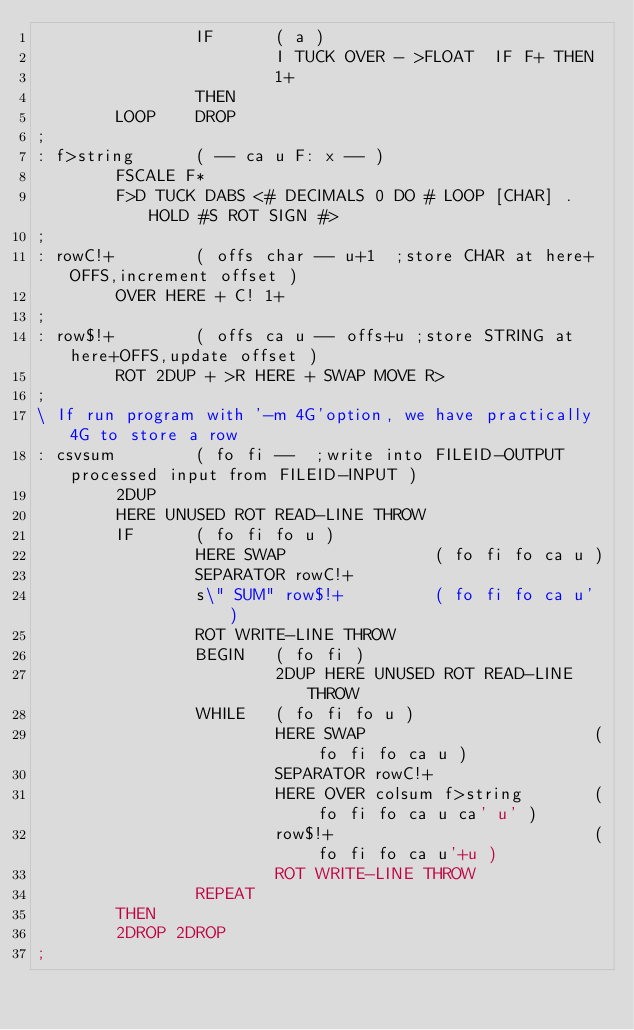<code> <loc_0><loc_0><loc_500><loc_500><_Forth_>                IF      ( a )
                        I TUCK OVER - >FLOAT  IF F+ THEN
                        1+
                THEN
        LOOP    DROP
;
: f>string      ( -- ca u F: x -- )
        FSCALE F*
        F>D TUCK DABS <# DECIMALS 0 DO # LOOP [CHAR] . HOLD #S ROT SIGN #>
;
: rowC!+        ( offs char -- u+1  ;store CHAR at here+OFFS,increment offset )
        OVER HERE + C! 1+
;
: row$!+        ( offs ca u -- offs+u ;store STRING at here+OFFS,update offset )
        ROT 2DUP + >R HERE + SWAP MOVE R>
;
\ If run program with '-m 4G'option, we have practically 4G to store a row
: csvsum        ( fo fi --  ;write into FILEID-OUTPUT processed input from FILEID-INPUT )
        2DUP
        HERE UNUSED ROT READ-LINE THROW
        IF      ( fo fi fo u )
                HERE SWAP               ( fo fi fo ca u )
                SEPARATOR rowC!+
                s\" SUM" row$!+         ( fo fi fo ca u' )
                ROT WRITE-LINE THROW
                BEGIN   ( fo fi )
                        2DUP HERE UNUSED ROT READ-LINE THROW
                WHILE   ( fo fi fo u )
                        HERE SWAP                       ( fo fi fo ca u )
                        SEPARATOR rowC!+
                        HERE OVER colsum f>string       ( fo fi fo ca u ca' u' )
                        row$!+                          ( fo fi fo ca u'+u )
                        ROT WRITE-LINE THROW
                REPEAT
        THEN
        2DROP 2DROP
;
</code> 